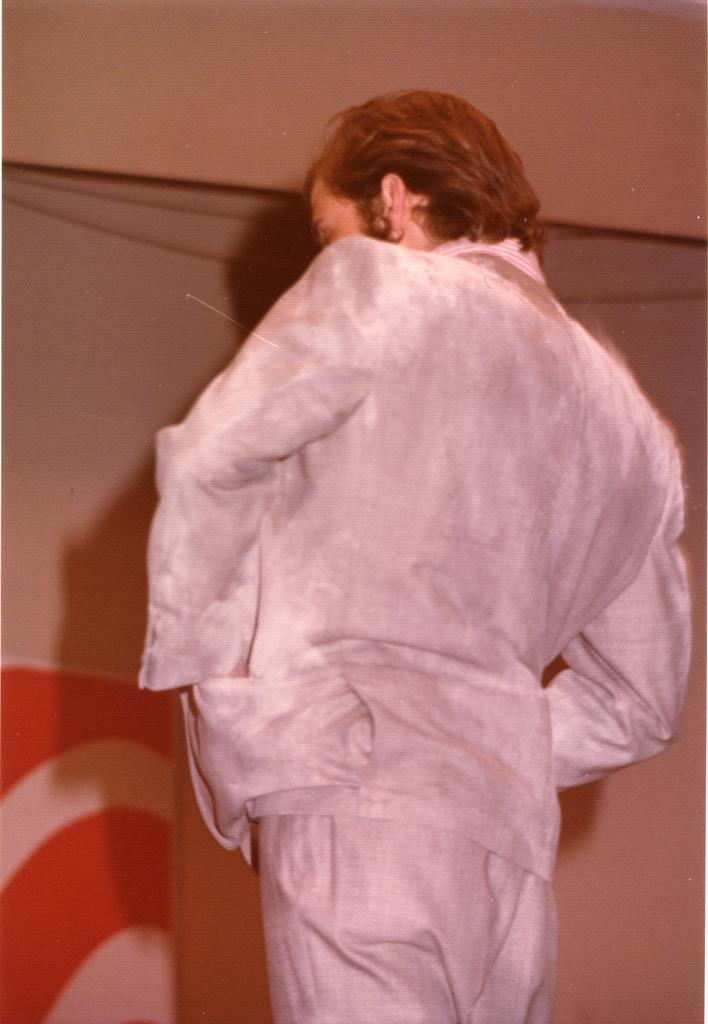What is the main subject of the image? There is a man in the image. What is the man doing in the image? The man is standing. Can you describe the object behind the man? Unfortunately, the provided facts do not give any information about the object behind the man. What type of juice is the man drinking in the image? There is no juice present in the image, as the man is standing and there is no mention of any beverage. 